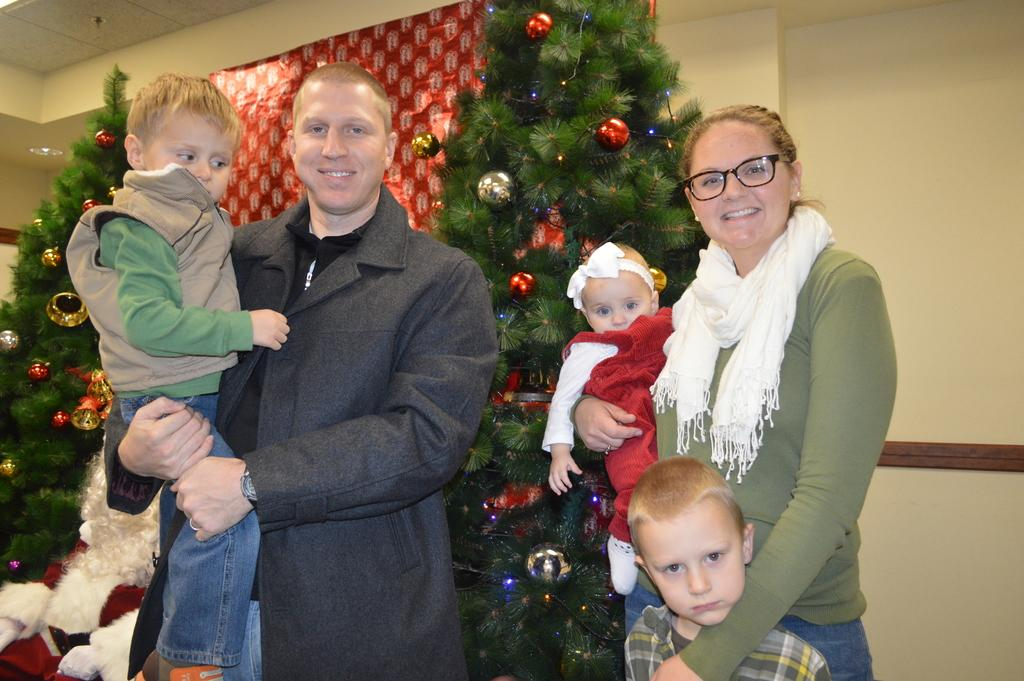Who are the people in the foreground of the image? There is a man, a woman, and children in the foreground of the image. What is the setting or occasion suggested by the presence of Christmas trees and Santa in the background? The setting or occasion suggested by the presence of Christmas trees and Santa in the background is likely a Christmas event or gathering. What else can be seen in the background of the image? There is a poster in the background of the image. How many cherries are on the trousers of the man in the image? There are no cherries or trousers mentioned in the image; the man is not described as wearing any specific clothing. What type of poison is being used to decorate the Christmas trees in the image? There is no mention of poison in the image; the Christmas trees are likely decorated with traditional ornaments and lights. 